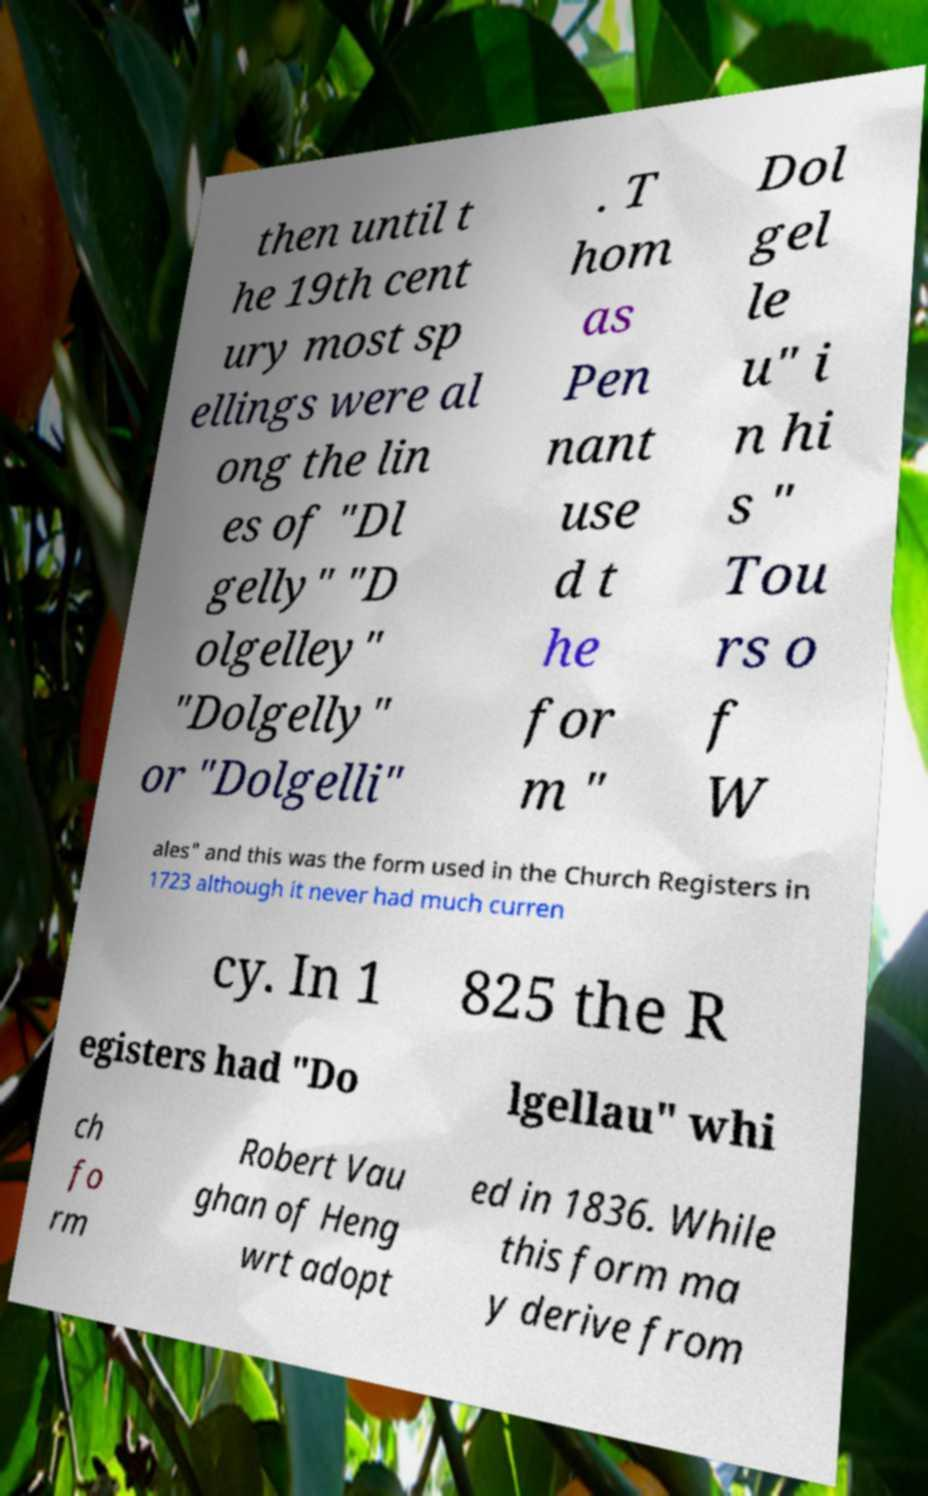Can you accurately transcribe the text from the provided image for me? then until t he 19th cent ury most sp ellings were al ong the lin es of "Dl gelly" "D olgelley" "Dolgelly" or "Dolgelli" . T hom as Pen nant use d t he for m " Dol gel le u" i n hi s " Tou rs o f W ales" and this was the form used in the Church Registers in 1723 although it never had much curren cy. In 1 825 the R egisters had "Do lgellau" whi ch fo rm Robert Vau ghan of Heng wrt adopt ed in 1836. While this form ma y derive from 